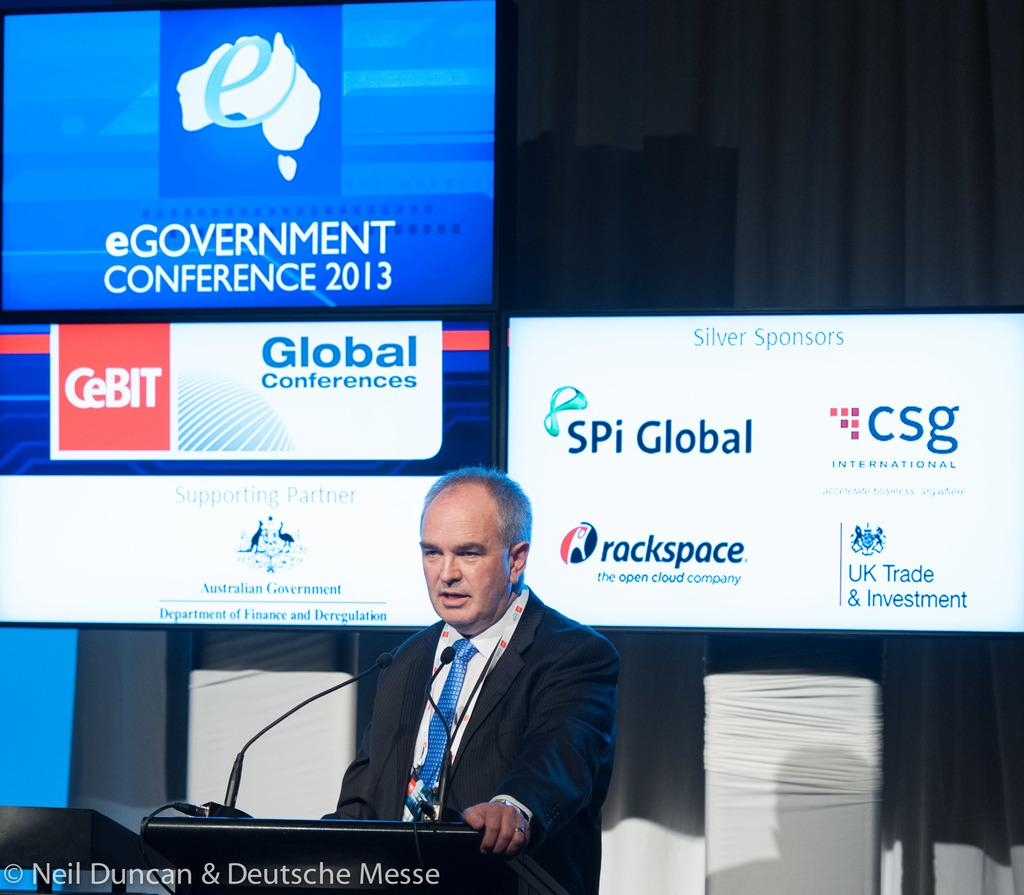<image>
Give a short and clear explanation of the subsequent image. A man is talking behind a podium with several adverts behind him like spi global. 